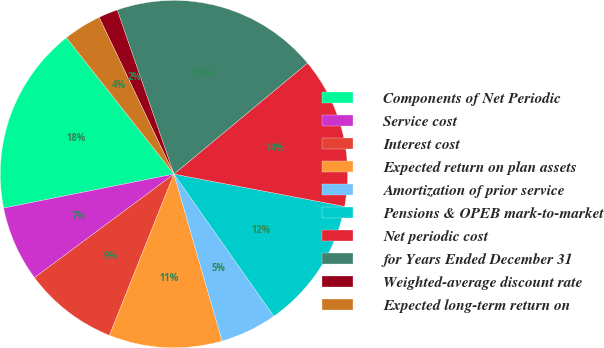<chart> <loc_0><loc_0><loc_500><loc_500><pie_chart><fcel>Components of Net Periodic<fcel>Service cost<fcel>Interest cost<fcel>Expected return on plan assets<fcel>Amortization of prior service<fcel>Pensions & OPEB mark-to-market<fcel>Net periodic cost<fcel>for Years Ended December 31<fcel>Weighted-average discount rate<fcel>Expected long-term return on<nl><fcel>17.51%<fcel>7.03%<fcel>8.78%<fcel>10.52%<fcel>5.28%<fcel>12.27%<fcel>14.02%<fcel>19.26%<fcel>1.79%<fcel>3.54%<nl></chart> 